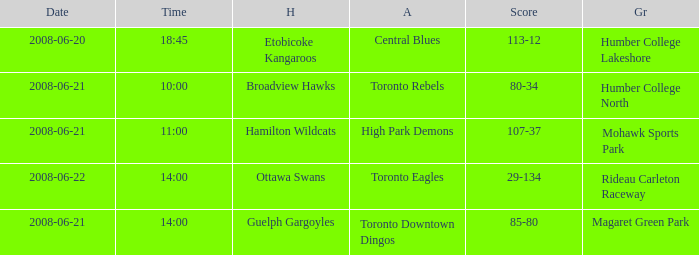What is the Ground with a Date that is 2008-06-20? Humber College Lakeshore. 